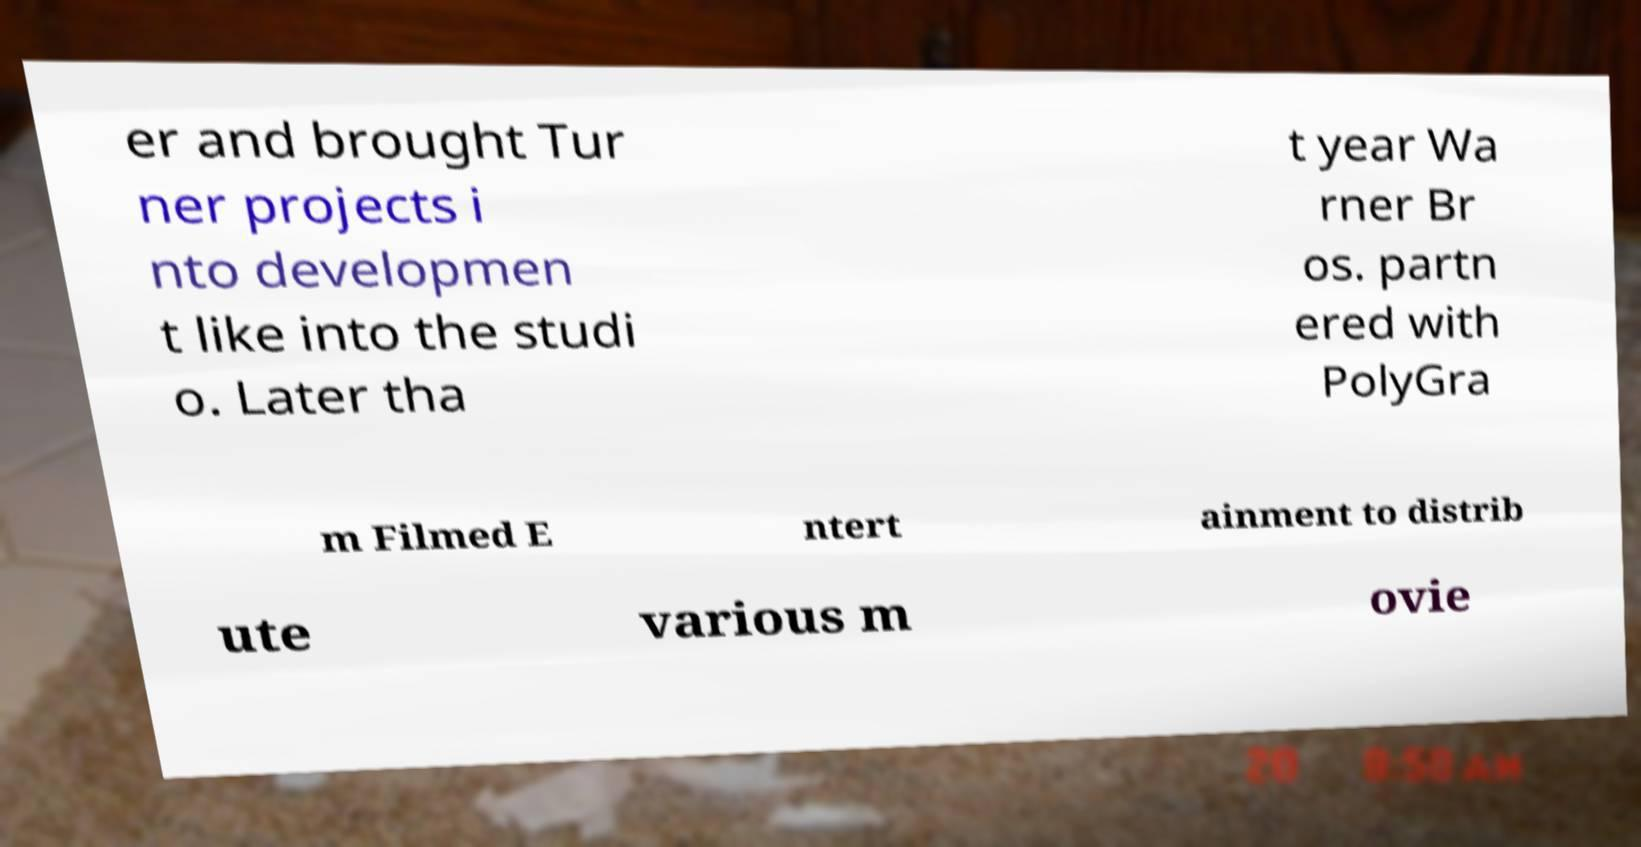Could you extract and type out the text from this image? er and brought Tur ner projects i nto developmen t like into the studi o. Later tha t year Wa rner Br os. partn ered with PolyGra m Filmed E ntert ainment to distrib ute various m ovie 